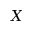Convert formula to latex. <formula><loc_0><loc_0><loc_500><loc_500>X</formula> 